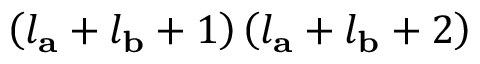<formula> <loc_0><loc_0><loc_500><loc_500>\left ( l _ { a } + l _ { b } + 1 \right ) \left ( l _ { a } + l _ { b } + 2 \right )</formula> 